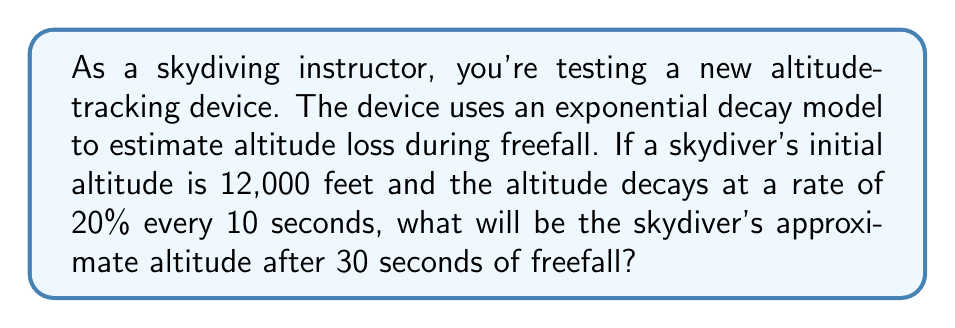Teach me how to tackle this problem. Let's approach this step-by-step using the exponential decay formula:

1) The exponential decay formula is:
   $$A(t) = A_0 \cdot (1-r)^{t/p}$$
   Where:
   $A(t)$ is the altitude at time $t$
   $A_0$ is the initial altitude
   $r$ is the decay rate
   $p$ is the time period for the given decay rate
   $t$ is the time elapsed

2) We know:
   $A_0 = 12,000$ feet
   $r = 20\% = 0.20$
   $p = 10$ seconds
   $t = 30$ seconds

3) Let's substitute these values into our formula:
   $$A(30) = 12,000 \cdot (1-0.20)^{30/10}$$

4) Simplify the exponent:
   $$A(30) = 12,000 \cdot (0.80)^3$$

5) Calculate the power:
   $$A(30) = 12,000 \cdot 0.512$$

6) Multiply:
   $$A(30) = 6,144$$

Therefore, after 30 seconds of freefall, the skydiver's approximate altitude will be 6,144 feet.
Answer: 6,144 feet 